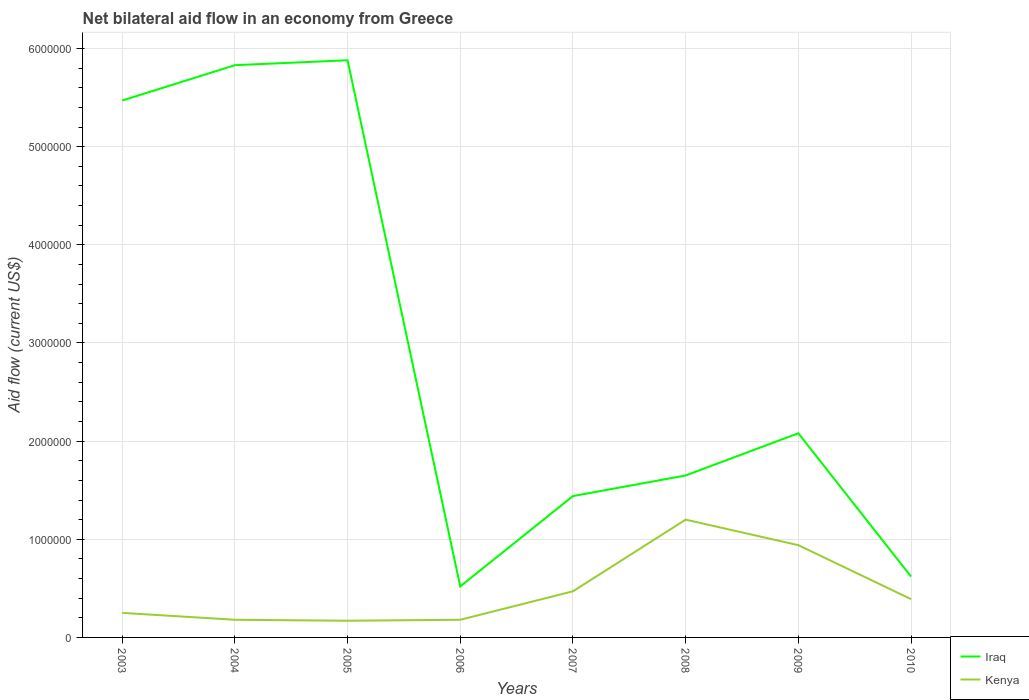How many different coloured lines are there?
Provide a short and direct response. 2. Does the line corresponding to Kenya intersect with the line corresponding to Iraq?
Provide a short and direct response. No. Across all years, what is the maximum net bilateral aid flow in Iraq?
Offer a terse response. 5.20e+05. What is the total net bilateral aid flow in Iraq in the graph?
Provide a succinct answer. 4.23e+06. What is the difference between the highest and the second highest net bilateral aid flow in Kenya?
Your answer should be compact. 1.03e+06. How many lines are there?
Offer a very short reply. 2. How many years are there in the graph?
Give a very brief answer. 8. What is the difference between two consecutive major ticks on the Y-axis?
Your answer should be compact. 1.00e+06. Are the values on the major ticks of Y-axis written in scientific E-notation?
Make the answer very short. No. Does the graph contain any zero values?
Offer a terse response. No. Does the graph contain grids?
Provide a short and direct response. Yes. What is the title of the graph?
Give a very brief answer. Net bilateral aid flow in an economy from Greece. Does "Benin" appear as one of the legend labels in the graph?
Make the answer very short. No. What is the label or title of the X-axis?
Keep it short and to the point. Years. What is the label or title of the Y-axis?
Provide a short and direct response. Aid flow (current US$). What is the Aid flow (current US$) in Iraq in 2003?
Your answer should be compact. 5.47e+06. What is the Aid flow (current US$) in Iraq in 2004?
Make the answer very short. 5.83e+06. What is the Aid flow (current US$) of Iraq in 2005?
Provide a succinct answer. 5.88e+06. What is the Aid flow (current US$) of Iraq in 2006?
Your answer should be very brief. 5.20e+05. What is the Aid flow (current US$) in Iraq in 2007?
Offer a terse response. 1.44e+06. What is the Aid flow (current US$) of Kenya in 2007?
Provide a short and direct response. 4.70e+05. What is the Aid flow (current US$) in Iraq in 2008?
Provide a succinct answer. 1.65e+06. What is the Aid flow (current US$) of Kenya in 2008?
Your answer should be very brief. 1.20e+06. What is the Aid flow (current US$) of Iraq in 2009?
Offer a terse response. 2.08e+06. What is the Aid flow (current US$) in Kenya in 2009?
Offer a very short reply. 9.40e+05. What is the Aid flow (current US$) of Iraq in 2010?
Your response must be concise. 6.20e+05. What is the Aid flow (current US$) of Kenya in 2010?
Offer a very short reply. 3.90e+05. Across all years, what is the maximum Aid flow (current US$) of Iraq?
Provide a succinct answer. 5.88e+06. Across all years, what is the maximum Aid flow (current US$) of Kenya?
Ensure brevity in your answer.  1.20e+06. Across all years, what is the minimum Aid flow (current US$) in Iraq?
Provide a succinct answer. 5.20e+05. What is the total Aid flow (current US$) in Iraq in the graph?
Make the answer very short. 2.35e+07. What is the total Aid flow (current US$) of Kenya in the graph?
Your response must be concise. 3.78e+06. What is the difference between the Aid flow (current US$) of Iraq in 2003 and that in 2004?
Your response must be concise. -3.60e+05. What is the difference between the Aid flow (current US$) in Iraq in 2003 and that in 2005?
Ensure brevity in your answer.  -4.10e+05. What is the difference between the Aid flow (current US$) in Kenya in 2003 and that in 2005?
Provide a succinct answer. 8.00e+04. What is the difference between the Aid flow (current US$) in Iraq in 2003 and that in 2006?
Provide a succinct answer. 4.95e+06. What is the difference between the Aid flow (current US$) in Kenya in 2003 and that in 2006?
Offer a very short reply. 7.00e+04. What is the difference between the Aid flow (current US$) in Iraq in 2003 and that in 2007?
Offer a terse response. 4.03e+06. What is the difference between the Aid flow (current US$) of Kenya in 2003 and that in 2007?
Offer a terse response. -2.20e+05. What is the difference between the Aid flow (current US$) in Iraq in 2003 and that in 2008?
Your answer should be very brief. 3.82e+06. What is the difference between the Aid flow (current US$) in Kenya in 2003 and that in 2008?
Your answer should be very brief. -9.50e+05. What is the difference between the Aid flow (current US$) of Iraq in 2003 and that in 2009?
Make the answer very short. 3.39e+06. What is the difference between the Aid flow (current US$) in Kenya in 2003 and that in 2009?
Your answer should be compact. -6.90e+05. What is the difference between the Aid flow (current US$) in Iraq in 2003 and that in 2010?
Provide a short and direct response. 4.85e+06. What is the difference between the Aid flow (current US$) in Kenya in 2003 and that in 2010?
Keep it short and to the point. -1.40e+05. What is the difference between the Aid flow (current US$) of Iraq in 2004 and that in 2005?
Provide a succinct answer. -5.00e+04. What is the difference between the Aid flow (current US$) of Kenya in 2004 and that in 2005?
Keep it short and to the point. 10000. What is the difference between the Aid flow (current US$) of Iraq in 2004 and that in 2006?
Ensure brevity in your answer.  5.31e+06. What is the difference between the Aid flow (current US$) of Iraq in 2004 and that in 2007?
Provide a short and direct response. 4.39e+06. What is the difference between the Aid flow (current US$) in Kenya in 2004 and that in 2007?
Your response must be concise. -2.90e+05. What is the difference between the Aid flow (current US$) in Iraq in 2004 and that in 2008?
Provide a short and direct response. 4.18e+06. What is the difference between the Aid flow (current US$) of Kenya in 2004 and that in 2008?
Offer a terse response. -1.02e+06. What is the difference between the Aid flow (current US$) in Iraq in 2004 and that in 2009?
Keep it short and to the point. 3.75e+06. What is the difference between the Aid flow (current US$) in Kenya in 2004 and that in 2009?
Your answer should be compact. -7.60e+05. What is the difference between the Aid flow (current US$) of Iraq in 2004 and that in 2010?
Ensure brevity in your answer.  5.21e+06. What is the difference between the Aid flow (current US$) of Iraq in 2005 and that in 2006?
Offer a very short reply. 5.36e+06. What is the difference between the Aid flow (current US$) of Kenya in 2005 and that in 2006?
Ensure brevity in your answer.  -10000. What is the difference between the Aid flow (current US$) in Iraq in 2005 and that in 2007?
Offer a terse response. 4.44e+06. What is the difference between the Aid flow (current US$) in Kenya in 2005 and that in 2007?
Make the answer very short. -3.00e+05. What is the difference between the Aid flow (current US$) of Iraq in 2005 and that in 2008?
Offer a very short reply. 4.23e+06. What is the difference between the Aid flow (current US$) of Kenya in 2005 and that in 2008?
Give a very brief answer. -1.03e+06. What is the difference between the Aid flow (current US$) of Iraq in 2005 and that in 2009?
Provide a succinct answer. 3.80e+06. What is the difference between the Aid flow (current US$) in Kenya in 2005 and that in 2009?
Offer a very short reply. -7.70e+05. What is the difference between the Aid flow (current US$) in Iraq in 2005 and that in 2010?
Keep it short and to the point. 5.26e+06. What is the difference between the Aid flow (current US$) in Kenya in 2005 and that in 2010?
Make the answer very short. -2.20e+05. What is the difference between the Aid flow (current US$) in Iraq in 2006 and that in 2007?
Provide a succinct answer. -9.20e+05. What is the difference between the Aid flow (current US$) in Kenya in 2006 and that in 2007?
Give a very brief answer. -2.90e+05. What is the difference between the Aid flow (current US$) in Iraq in 2006 and that in 2008?
Keep it short and to the point. -1.13e+06. What is the difference between the Aid flow (current US$) of Kenya in 2006 and that in 2008?
Provide a short and direct response. -1.02e+06. What is the difference between the Aid flow (current US$) of Iraq in 2006 and that in 2009?
Provide a short and direct response. -1.56e+06. What is the difference between the Aid flow (current US$) in Kenya in 2006 and that in 2009?
Make the answer very short. -7.60e+05. What is the difference between the Aid flow (current US$) of Kenya in 2007 and that in 2008?
Your answer should be very brief. -7.30e+05. What is the difference between the Aid flow (current US$) of Iraq in 2007 and that in 2009?
Your response must be concise. -6.40e+05. What is the difference between the Aid flow (current US$) in Kenya in 2007 and that in 2009?
Your response must be concise. -4.70e+05. What is the difference between the Aid flow (current US$) of Iraq in 2007 and that in 2010?
Provide a succinct answer. 8.20e+05. What is the difference between the Aid flow (current US$) in Iraq in 2008 and that in 2009?
Your answer should be very brief. -4.30e+05. What is the difference between the Aid flow (current US$) in Iraq in 2008 and that in 2010?
Offer a terse response. 1.03e+06. What is the difference between the Aid flow (current US$) of Kenya in 2008 and that in 2010?
Offer a terse response. 8.10e+05. What is the difference between the Aid flow (current US$) of Iraq in 2009 and that in 2010?
Offer a terse response. 1.46e+06. What is the difference between the Aid flow (current US$) of Kenya in 2009 and that in 2010?
Provide a succinct answer. 5.50e+05. What is the difference between the Aid flow (current US$) in Iraq in 2003 and the Aid flow (current US$) in Kenya in 2004?
Provide a short and direct response. 5.29e+06. What is the difference between the Aid flow (current US$) of Iraq in 2003 and the Aid flow (current US$) of Kenya in 2005?
Offer a terse response. 5.30e+06. What is the difference between the Aid flow (current US$) in Iraq in 2003 and the Aid flow (current US$) in Kenya in 2006?
Your answer should be very brief. 5.29e+06. What is the difference between the Aid flow (current US$) in Iraq in 2003 and the Aid flow (current US$) in Kenya in 2008?
Keep it short and to the point. 4.27e+06. What is the difference between the Aid flow (current US$) of Iraq in 2003 and the Aid flow (current US$) of Kenya in 2009?
Your response must be concise. 4.53e+06. What is the difference between the Aid flow (current US$) in Iraq in 2003 and the Aid flow (current US$) in Kenya in 2010?
Give a very brief answer. 5.08e+06. What is the difference between the Aid flow (current US$) of Iraq in 2004 and the Aid flow (current US$) of Kenya in 2005?
Provide a short and direct response. 5.66e+06. What is the difference between the Aid flow (current US$) of Iraq in 2004 and the Aid flow (current US$) of Kenya in 2006?
Your answer should be very brief. 5.65e+06. What is the difference between the Aid flow (current US$) of Iraq in 2004 and the Aid flow (current US$) of Kenya in 2007?
Ensure brevity in your answer.  5.36e+06. What is the difference between the Aid flow (current US$) in Iraq in 2004 and the Aid flow (current US$) in Kenya in 2008?
Offer a very short reply. 4.63e+06. What is the difference between the Aid flow (current US$) in Iraq in 2004 and the Aid flow (current US$) in Kenya in 2009?
Ensure brevity in your answer.  4.89e+06. What is the difference between the Aid flow (current US$) of Iraq in 2004 and the Aid flow (current US$) of Kenya in 2010?
Ensure brevity in your answer.  5.44e+06. What is the difference between the Aid flow (current US$) in Iraq in 2005 and the Aid flow (current US$) in Kenya in 2006?
Offer a very short reply. 5.70e+06. What is the difference between the Aid flow (current US$) of Iraq in 2005 and the Aid flow (current US$) of Kenya in 2007?
Your answer should be compact. 5.41e+06. What is the difference between the Aid flow (current US$) of Iraq in 2005 and the Aid flow (current US$) of Kenya in 2008?
Your answer should be very brief. 4.68e+06. What is the difference between the Aid flow (current US$) of Iraq in 2005 and the Aid flow (current US$) of Kenya in 2009?
Provide a succinct answer. 4.94e+06. What is the difference between the Aid flow (current US$) of Iraq in 2005 and the Aid flow (current US$) of Kenya in 2010?
Your response must be concise. 5.49e+06. What is the difference between the Aid flow (current US$) of Iraq in 2006 and the Aid flow (current US$) of Kenya in 2008?
Make the answer very short. -6.80e+05. What is the difference between the Aid flow (current US$) of Iraq in 2006 and the Aid flow (current US$) of Kenya in 2009?
Keep it short and to the point. -4.20e+05. What is the difference between the Aid flow (current US$) of Iraq in 2007 and the Aid flow (current US$) of Kenya in 2008?
Provide a short and direct response. 2.40e+05. What is the difference between the Aid flow (current US$) of Iraq in 2007 and the Aid flow (current US$) of Kenya in 2010?
Provide a short and direct response. 1.05e+06. What is the difference between the Aid flow (current US$) of Iraq in 2008 and the Aid flow (current US$) of Kenya in 2009?
Ensure brevity in your answer.  7.10e+05. What is the difference between the Aid flow (current US$) in Iraq in 2008 and the Aid flow (current US$) in Kenya in 2010?
Keep it short and to the point. 1.26e+06. What is the difference between the Aid flow (current US$) of Iraq in 2009 and the Aid flow (current US$) of Kenya in 2010?
Provide a short and direct response. 1.69e+06. What is the average Aid flow (current US$) of Iraq per year?
Your answer should be very brief. 2.94e+06. What is the average Aid flow (current US$) in Kenya per year?
Your response must be concise. 4.72e+05. In the year 2003, what is the difference between the Aid flow (current US$) of Iraq and Aid flow (current US$) of Kenya?
Keep it short and to the point. 5.22e+06. In the year 2004, what is the difference between the Aid flow (current US$) in Iraq and Aid flow (current US$) in Kenya?
Provide a succinct answer. 5.65e+06. In the year 2005, what is the difference between the Aid flow (current US$) of Iraq and Aid flow (current US$) of Kenya?
Give a very brief answer. 5.71e+06. In the year 2006, what is the difference between the Aid flow (current US$) in Iraq and Aid flow (current US$) in Kenya?
Your answer should be compact. 3.40e+05. In the year 2007, what is the difference between the Aid flow (current US$) of Iraq and Aid flow (current US$) of Kenya?
Offer a terse response. 9.70e+05. In the year 2009, what is the difference between the Aid flow (current US$) in Iraq and Aid flow (current US$) in Kenya?
Provide a short and direct response. 1.14e+06. What is the ratio of the Aid flow (current US$) of Iraq in 2003 to that in 2004?
Provide a succinct answer. 0.94. What is the ratio of the Aid flow (current US$) in Kenya in 2003 to that in 2004?
Keep it short and to the point. 1.39. What is the ratio of the Aid flow (current US$) of Iraq in 2003 to that in 2005?
Offer a terse response. 0.93. What is the ratio of the Aid flow (current US$) in Kenya in 2003 to that in 2005?
Give a very brief answer. 1.47. What is the ratio of the Aid flow (current US$) in Iraq in 2003 to that in 2006?
Provide a short and direct response. 10.52. What is the ratio of the Aid flow (current US$) of Kenya in 2003 to that in 2006?
Give a very brief answer. 1.39. What is the ratio of the Aid flow (current US$) of Iraq in 2003 to that in 2007?
Make the answer very short. 3.8. What is the ratio of the Aid flow (current US$) of Kenya in 2003 to that in 2007?
Keep it short and to the point. 0.53. What is the ratio of the Aid flow (current US$) in Iraq in 2003 to that in 2008?
Provide a succinct answer. 3.32. What is the ratio of the Aid flow (current US$) of Kenya in 2003 to that in 2008?
Ensure brevity in your answer.  0.21. What is the ratio of the Aid flow (current US$) in Iraq in 2003 to that in 2009?
Provide a short and direct response. 2.63. What is the ratio of the Aid flow (current US$) in Kenya in 2003 to that in 2009?
Your answer should be compact. 0.27. What is the ratio of the Aid flow (current US$) in Iraq in 2003 to that in 2010?
Your answer should be compact. 8.82. What is the ratio of the Aid flow (current US$) in Kenya in 2003 to that in 2010?
Provide a succinct answer. 0.64. What is the ratio of the Aid flow (current US$) of Iraq in 2004 to that in 2005?
Give a very brief answer. 0.99. What is the ratio of the Aid flow (current US$) in Kenya in 2004 to that in 2005?
Make the answer very short. 1.06. What is the ratio of the Aid flow (current US$) in Iraq in 2004 to that in 2006?
Provide a short and direct response. 11.21. What is the ratio of the Aid flow (current US$) of Iraq in 2004 to that in 2007?
Make the answer very short. 4.05. What is the ratio of the Aid flow (current US$) of Kenya in 2004 to that in 2007?
Keep it short and to the point. 0.38. What is the ratio of the Aid flow (current US$) of Iraq in 2004 to that in 2008?
Make the answer very short. 3.53. What is the ratio of the Aid flow (current US$) in Kenya in 2004 to that in 2008?
Provide a succinct answer. 0.15. What is the ratio of the Aid flow (current US$) of Iraq in 2004 to that in 2009?
Make the answer very short. 2.8. What is the ratio of the Aid flow (current US$) of Kenya in 2004 to that in 2009?
Give a very brief answer. 0.19. What is the ratio of the Aid flow (current US$) of Iraq in 2004 to that in 2010?
Your response must be concise. 9.4. What is the ratio of the Aid flow (current US$) in Kenya in 2004 to that in 2010?
Make the answer very short. 0.46. What is the ratio of the Aid flow (current US$) in Iraq in 2005 to that in 2006?
Your answer should be very brief. 11.31. What is the ratio of the Aid flow (current US$) in Iraq in 2005 to that in 2007?
Provide a short and direct response. 4.08. What is the ratio of the Aid flow (current US$) of Kenya in 2005 to that in 2007?
Your response must be concise. 0.36. What is the ratio of the Aid flow (current US$) of Iraq in 2005 to that in 2008?
Offer a very short reply. 3.56. What is the ratio of the Aid flow (current US$) in Kenya in 2005 to that in 2008?
Provide a short and direct response. 0.14. What is the ratio of the Aid flow (current US$) in Iraq in 2005 to that in 2009?
Your answer should be compact. 2.83. What is the ratio of the Aid flow (current US$) in Kenya in 2005 to that in 2009?
Your response must be concise. 0.18. What is the ratio of the Aid flow (current US$) of Iraq in 2005 to that in 2010?
Offer a very short reply. 9.48. What is the ratio of the Aid flow (current US$) in Kenya in 2005 to that in 2010?
Provide a short and direct response. 0.44. What is the ratio of the Aid flow (current US$) in Iraq in 2006 to that in 2007?
Provide a succinct answer. 0.36. What is the ratio of the Aid flow (current US$) of Kenya in 2006 to that in 2007?
Offer a very short reply. 0.38. What is the ratio of the Aid flow (current US$) of Iraq in 2006 to that in 2008?
Offer a very short reply. 0.32. What is the ratio of the Aid flow (current US$) of Iraq in 2006 to that in 2009?
Make the answer very short. 0.25. What is the ratio of the Aid flow (current US$) of Kenya in 2006 to that in 2009?
Your answer should be compact. 0.19. What is the ratio of the Aid flow (current US$) of Iraq in 2006 to that in 2010?
Keep it short and to the point. 0.84. What is the ratio of the Aid flow (current US$) in Kenya in 2006 to that in 2010?
Offer a very short reply. 0.46. What is the ratio of the Aid flow (current US$) of Iraq in 2007 to that in 2008?
Provide a succinct answer. 0.87. What is the ratio of the Aid flow (current US$) of Kenya in 2007 to that in 2008?
Offer a very short reply. 0.39. What is the ratio of the Aid flow (current US$) in Iraq in 2007 to that in 2009?
Your answer should be compact. 0.69. What is the ratio of the Aid flow (current US$) in Kenya in 2007 to that in 2009?
Your response must be concise. 0.5. What is the ratio of the Aid flow (current US$) in Iraq in 2007 to that in 2010?
Provide a succinct answer. 2.32. What is the ratio of the Aid flow (current US$) in Kenya in 2007 to that in 2010?
Make the answer very short. 1.21. What is the ratio of the Aid flow (current US$) in Iraq in 2008 to that in 2009?
Offer a very short reply. 0.79. What is the ratio of the Aid flow (current US$) in Kenya in 2008 to that in 2009?
Give a very brief answer. 1.28. What is the ratio of the Aid flow (current US$) of Iraq in 2008 to that in 2010?
Give a very brief answer. 2.66. What is the ratio of the Aid flow (current US$) in Kenya in 2008 to that in 2010?
Offer a very short reply. 3.08. What is the ratio of the Aid flow (current US$) of Iraq in 2009 to that in 2010?
Offer a terse response. 3.35. What is the ratio of the Aid flow (current US$) in Kenya in 2009 to that in 2010?
Provide a succinct answer. 2.41. What is the difference between the highest and the second highest Aid flow (current US$) of Kenya?
Provide a short and direct response. 2.60e+05. What is the difference between the highest and the lowest Aid flow (current US$) of Iraq?
Provide a short and direct response. 5.36e+06. What is the difference between the highest and the lowest Aid flow (current US$) of Kenya?
Keep it short and to the point. 1.03e+06. 